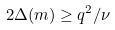<formula> <loc_0><loc_0><loc_500><loc_500>2 \Delta ( { m } ) \geq q ^ { 2 } / \nu</formula> 